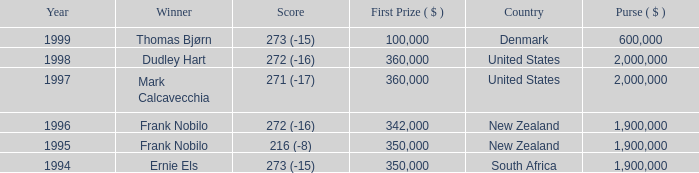What was the total purse in the years after 1996 with a score of 272 (-16) when frank nobilo won? None. 